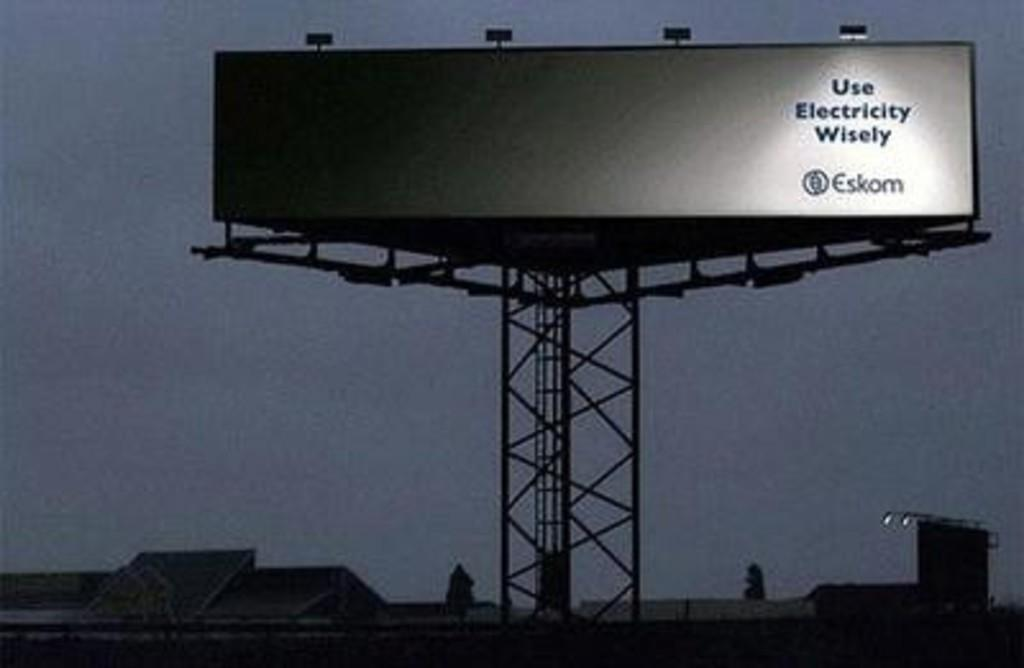<image>
Summarize the visual content of the image. a Use electricity wisely billboard outside at night 